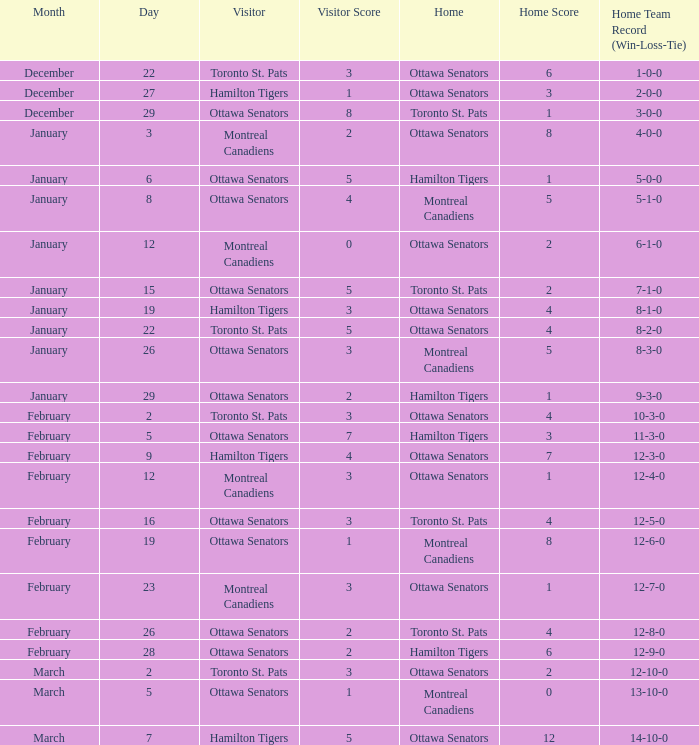What is the score of the game on January 12? 0–2. 